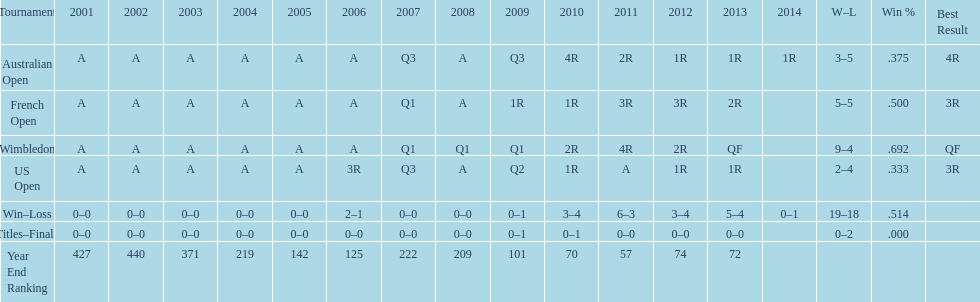Which tournament has the largest total win record? Wimbledon. 